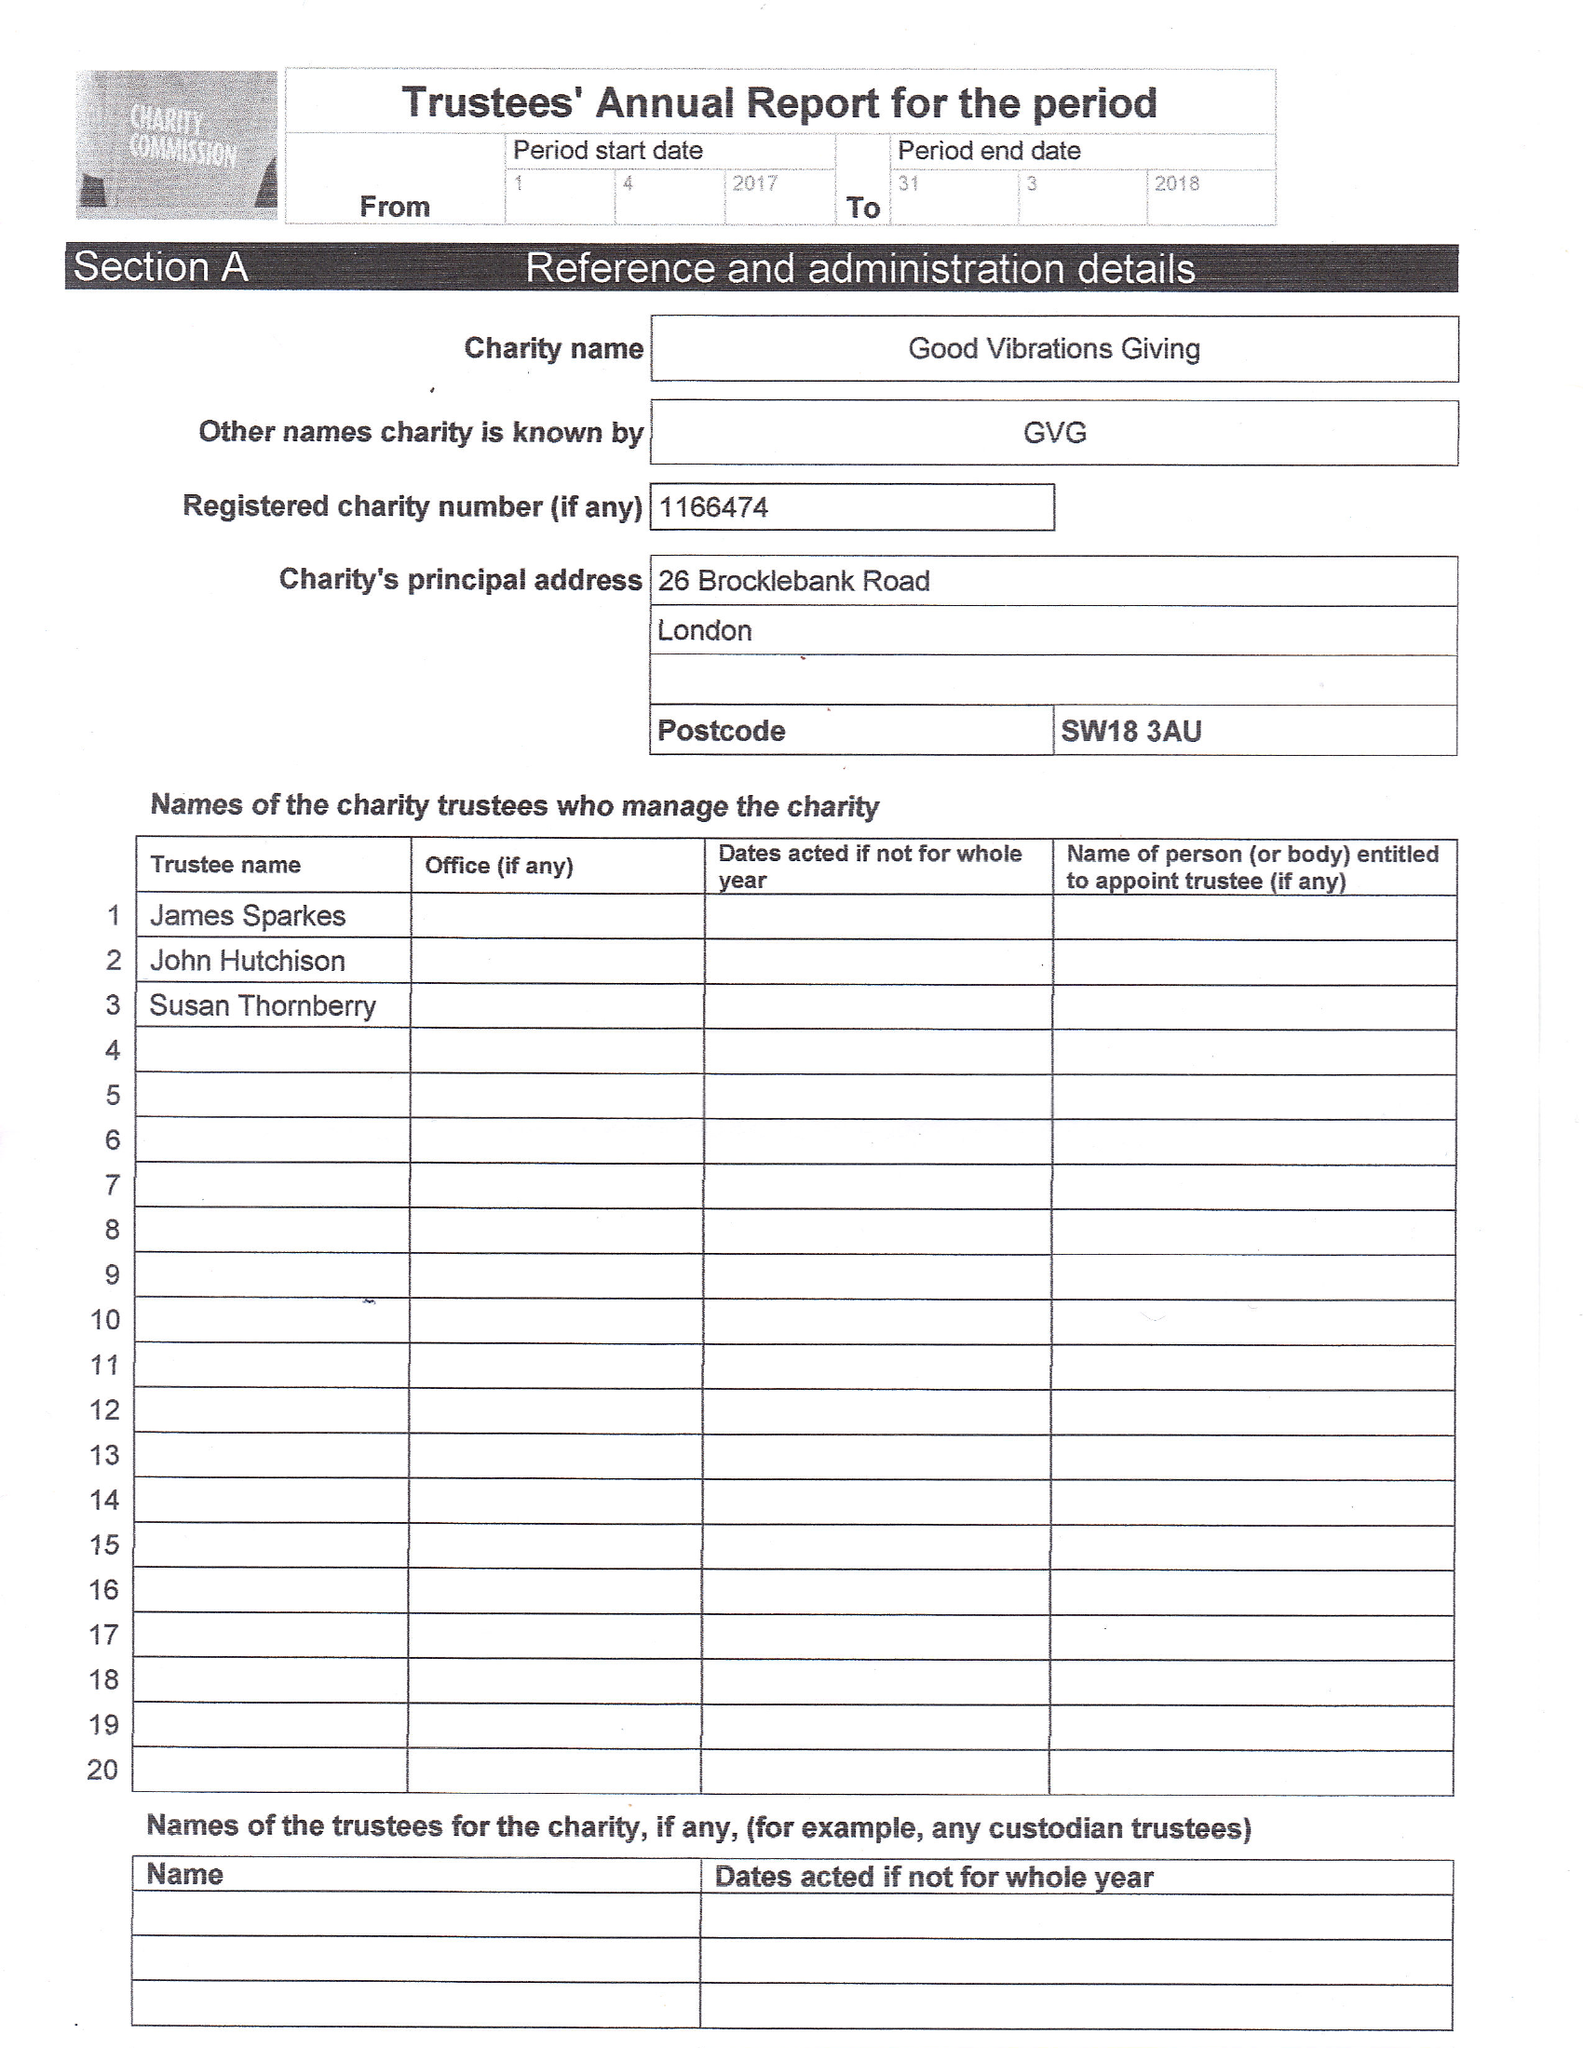What is the value for the report_date?
Answer the question using a single word or phrase. 2018-03-31 